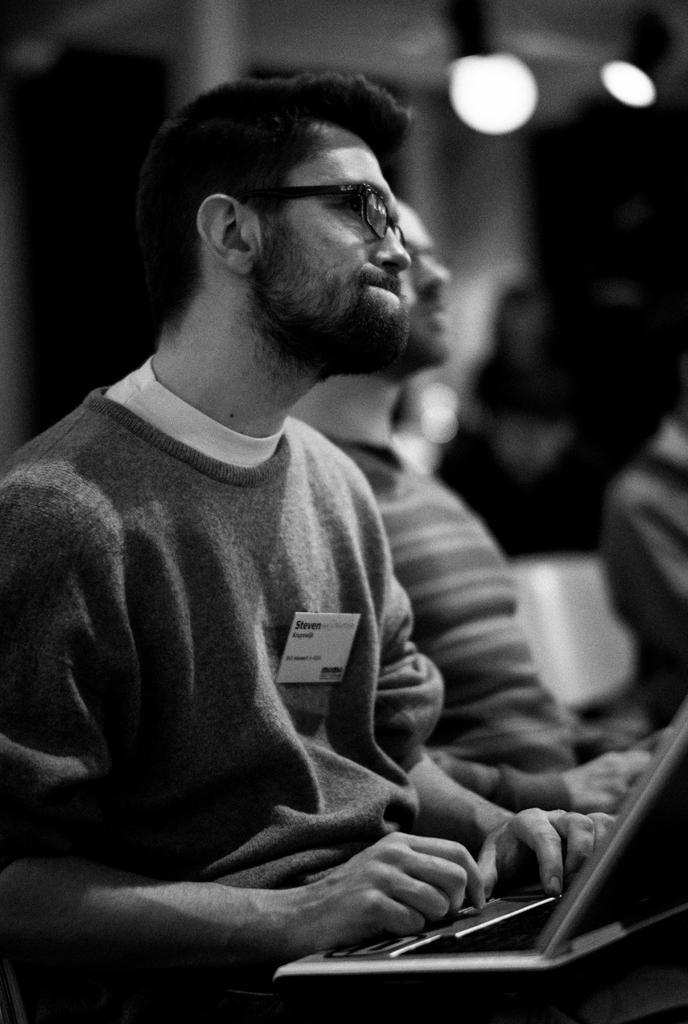How would you summarize this image in a sentence or two? This is a black and white image, we can see there is one person sitting and holding a laptop, and there are some other persons in the background. 